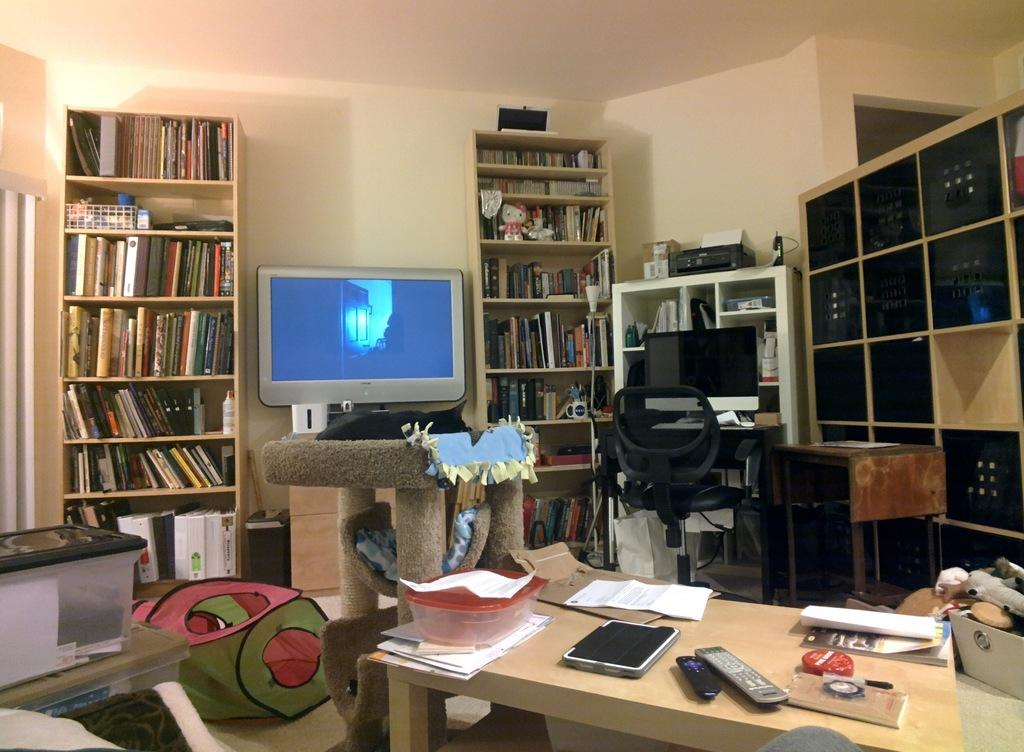What piece of furniture is present in the room? There is a table in the room. What items can be found on the table? There is a tab, a remote, a paper, a book, and a box on the table. What type of storage is available in the room? There are racks with books in the room. What is the seating arrangement in the room? There is a chair in the room. What electronic devices are present in the room? There is a monitor and a printer in the room. What type of crime is being committed in the room? There is no indication of any crime being committed in the room; the image only shows a table, racks with books, a chair, a monitor, and a printer. Is there any coal visible in the room? There is no coal present in the room; the image only shows a table, racks with books, a chair, a monitor, and a printer. 